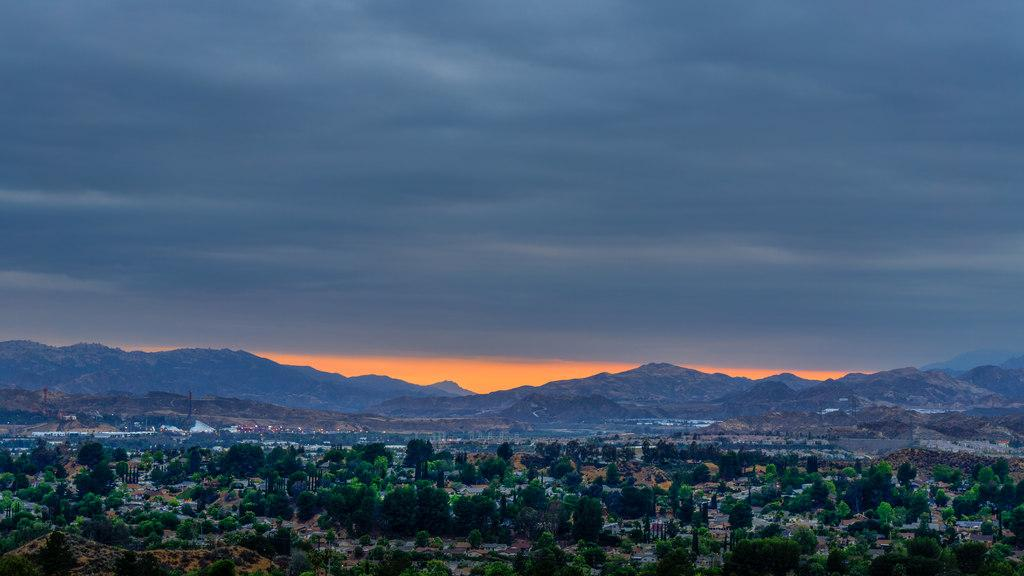What type of natural elements can be seen in the image? There are trees in the image. What type of landscape feature is visible in the background? There are mountains visible in the background of the image. What is visible at the top of the image? The sky is visible at the top of the image. What can be observed in the sky? Clouds are present in the sky. What type of tools does the carpenter use in the image? There is no carpenter present in the image. What arithmetic problem is being solved in the image? There is no arithmetic problem visible in the image. 